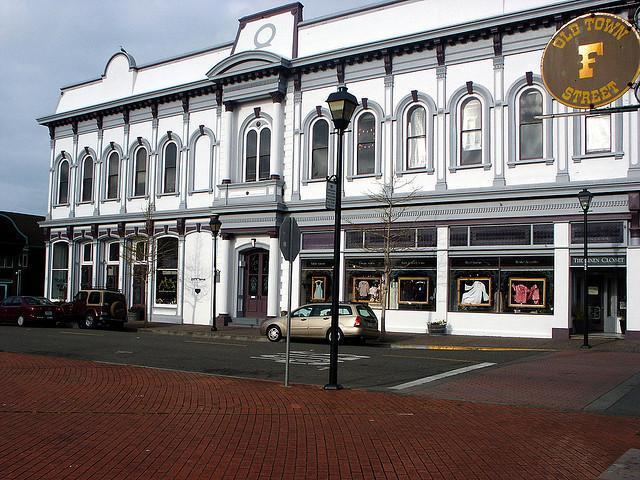How many cars are there?
Give a very brief answer. 2. How many people are wearing a red hat?
Give a very brief answer. 0. 